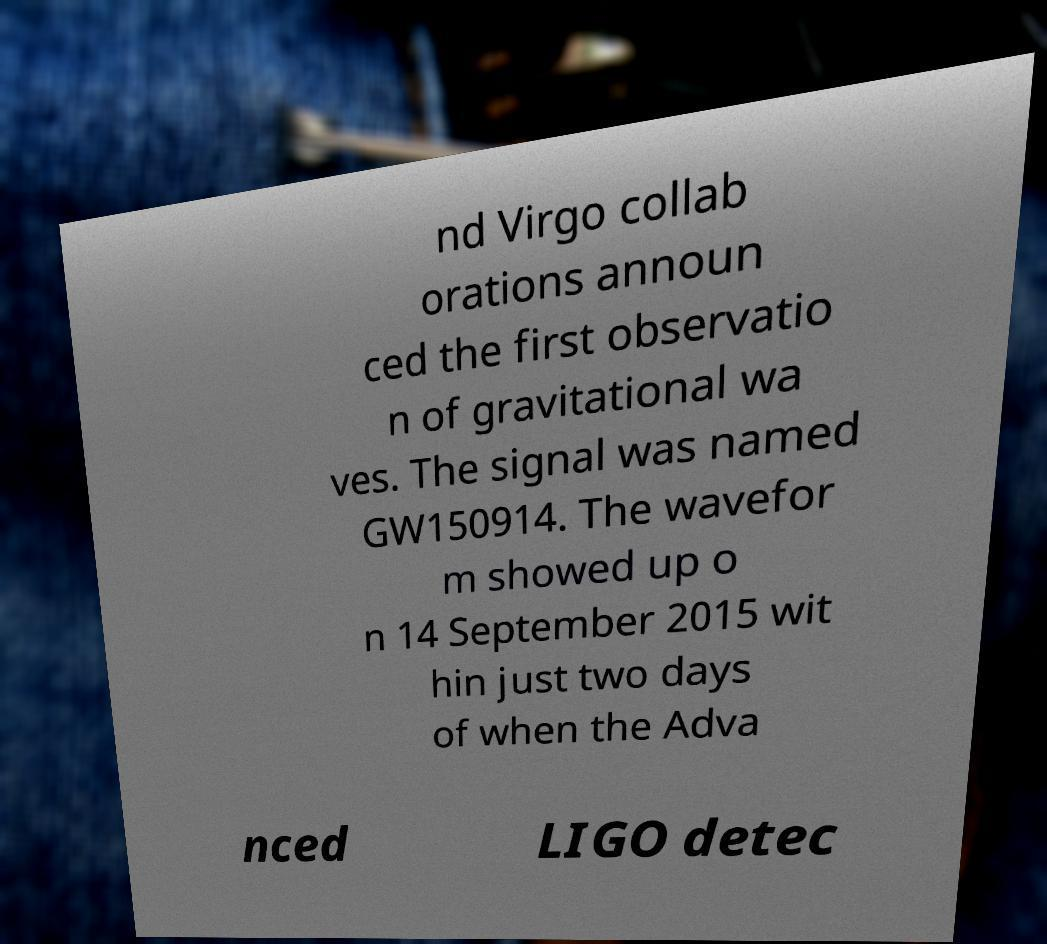There's text embedded in this image that I need extracted. Can you transcribe it verbatim? nd Virgo collab orations announ ced the first observatio n of gravitational wa ves. The signal was named GW150914. The wavefor m showed up o n 14 September 2015 wit hin just two days of when the Adva nced LIGO detec 